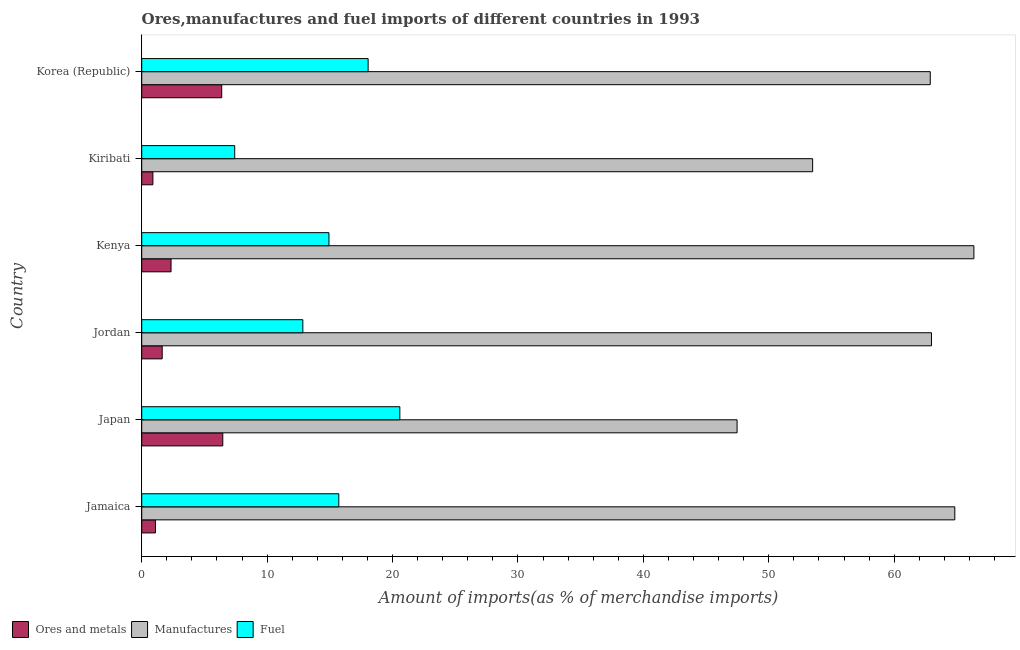How many different coloured bars are there?
Offer a terse response. 3. How many bars are there on the 2nd tick from the top?
Provide a short and direct response. 3. What is the label of the 3rd group of bars from the top?
Your answer should be compact. Kenya. In how many cases, is the number of bars for a given country not equal to the number of legend labels?
Offer a terse response. 0. What is the percentage of fuel imports in Jamaica?
Your answer should be compact. 15.72. Across all countries, what is the maximum percentage of fuel imports?
Offer a terse response. 20.58. Across all countries, what is the minimum percentage of manufactures imports?
Ensure brevity in your answer.  47.47. In which country was the percentage of manufactures imports minimum?
Give a very brief answer. Japan. What is the total percentage of ores and metals imports in the graph?
Your answer should be compact. 18.8. What is the difference between the percentage of fuel imports in Jordan and that in Kenya?
Keep it short and to the point. -2.08. What is the difference between the percentage of fuel imports in Korea (Republic) and the percentage of ores and metals imports in Jordan?
Ensure brevity in your answer.  16.42. What is the average percentage of fuel imports per country?
Keep it short and to the point. 14.92. What is the difference between the percentage of manufactures imports and percentage of fuel imports in Japan?
Your answer should be very brief. 26.89. What is the ratio of the percentage of manufactures imports in Jamaica to that in Korea (Republic)?
Offer a terse response. 1.03. Is the percentage of ores and metals imports in Kiribati less than that in Korea (Republic)?
Provide a succinct answer. Yes. What is the difference between the highest and the second highest percentage of ores and metals imports?
Keep it short and to the point. 0.08. What is the difference between the highest and the lowest percentage of ores and metals imports?
Ensure brevity in your answer.  5.57. In how many countries, is the percentage of manufactures imports greater than the average percentage of manufactures imports taken over all countries?
Provide a succinct answer. 4. Is the sum of the percentage of ores and metals imports in Japan and Jordan greater than the maximum percentage of manufactures imports across all countries?
Your answer should be compact. No. What does the 2nd bar from the top in Kiribati represents?
Keep it short and to the point. Manufactures. What does the 3rd bar from the bottom in Korea (Republic) represents?
Your response must be concise. Fuel. Is it the case that in every country, the sum of the percentage of ores and metals imports and percentage of manufactures imports is greater than the percentage of fuel imports?
Your response must be concise. Yes. How many countries are there in the graph?
Provide a succinct answer. 6. What is the difference between two consecutive major ticks on the X-axis?
Your answer should be very brief. 10. Are the values on the major ticks of X-axis written in scientific E-notation?
Make the answer very short. No. Does the graph contain any zero values?
Your answer should be compact. No. Where does the legend appear in the graph?
Keep it short and to the point. Bottom left. How are the legend labels stacked?
Make the answer very short. Horizontal. What is the title of the graph?
Your answer should be very brief. Ores,manufactures and fuel imports of different countries in 1993. What is the label or title of the X-axis?
Ensure brevity in your answer.  Amount of imports(as % of merchandise imports). What is the Amount of imports(as % of merchandise imports) of Ores and metals in Jamaica?
Your answer should be compact. 1.1. What is the Amount of imports(as % of merchandise imports) in Manufactures in Jamaica?
Make the answer very short. 64.84. What is the Amount of imports(as % of merchandise imports) in Fuel in Jamaica?
Offer a very short reply. 15.72. What is the Amount of imports(as % of merchandise imports) of Ores and metals in Japan?
Offer a terse response. 6.46. What is the Amount of imports(as % of merchandise imports) of Manufactures in Japan?
Offer a very short reply. 47.47. What is the Amount of imports(as % of merchandise imports) in Fuel in Japan?
Provide a short and direct response. 20.58. What is the Amount of imports(as % of merchandise imports) of Ores and metals in Jordan?
Offer a very short reply. 1.63. What is the Amount of imports(as % of merchandise imports) of Manufactures in Jordan?
Offer a terse response. 62.97. What is the Amount of imports(as % of merchandise imports) in Fuel in Jordan?
Your response must be concise. 12.85. What is the Amount of imports(as % of merchandise imports) of Ores and metals in Kenya?
Offer a terse response. 2.34. What is the Amount of imports(as % of merchandise imports) in Manufactures in Kenya?
Offer a very short reply. 66.36. What is the Amount of imports(as % of merchandise imports) of Fuel in Kenya?
Keep it short and to the point. 14.93. What is the Amount of imports(as % of merchandise imports) of Ores and metals in Kiribati?
Offer a very short reply. 0.89. What is the Amount of imports(as % of merchandise imports) in Manufactures in Kiribati?
Your response must be concise. 53.5. What is the Amount of imports(as % of merchandise imports) in Fuel in Kiribati?
Provide a short and direct response. 7.41. What is the Amount of imports(as % of merchandise imports) in Ores and metals in Korea (Republic)?
Ensure brevity in your answer.  6.38. What is the Amount of imports(as % of merchandise imports) of Manufactures in Korea (Republic)?
Your answer should be very brief. 62.88. What is the Amount of imports(as % of merchandise imports) in Fuel in Korea (Republic)?
Keep it short and to the point. 18.05. Across all countries, what is the maximum Amount of imports(as % of merchandise imports) in Ores and metals?
Offer a very short reply. 6.46. Across all countries, what is the maximum Amount of imports(as % of merchandise imports) in Manufactures?
Your response must be concise. 66.36. Across all countries, what is the maximum Amount of imports(as % of merchandise imports) of Fuel?
Provide a short and direct response. 20.58. Across all countries, what is the minimum Amount of imports(as % of merchandise imports) of Ores and metals?
Ensure brevity in your answer.  0.89. Across all countries, what is the minimum Amount of imports(as % of merchandise imports) of Manufactures?
Provide a short and direct response. 47.47. Across all countries, what is the minimum Amount of imports(as % of merchandise imports) of Fuel?
Your answer should be compact. 7.41. What is the total Amount of imports(as % of merchandise imports) in Ores and metals in the graph?
Provide a short and direct response. 18.8. What is the total Amount of imports(as % of merchandise imports) in Manufactures in the graph?
Your answer should be very brief. 358.02. What is the total Amount of imports(as % of merchandise imports) of Fuel in the graph?
Offer a terse response. 89.55. What is the difference between the Amount of imports(as % of merchandise imports) of Ores and metals in Jamaica and that in Japan?
Ensure brevity in your answer.  -5.37. What is the difference between the Amount of imports(as % of merchandise imports) of Manufactures in Jamaica and that in Japan?
Your answer should be compact. 17.36. What is the difference between the Amount of imports(as % of merchandise imports) in Fuel in Jamaica and that in Japan?
Your answer should be very brief. -4.87. What is the difference between the Amount of imports(as % of merchandise imports) of Ores and metals in Jamaica and that in Jordan?
Your answer should be compact. -0.54. What is the difference between the Amount of imports(as % of merchandise imports) of Manufactures in Jamaica and that in Jordan?
Your response must be concise. 1.86. What is the difference between the Amount of imports(as % of merchandise imports) of Fuel in Jamaica and that in Jordan?
Provide a short and direct response. 2.87. What is the difference between the Amount of imports(as % of merchandise imports) in Ores and metals in Jamaica and that in Kenya?
Offer a terse response. -1.24. What is the difference between the Amount of imports(as % of merchandise imports) of Manufactures in Jamaica and that in Kenya?
Your response must be concise. -1.52. What is the difference between the Amount of imports(as % of merchandise imports) in Fuel in Jamaica and that in Kenya?
Offer a very short reply. 0.79. What is the difference between the Amount of imports(as % of merchandise imports) in Ores and metals in Jamaica and that in Kiribati?
Offer a terse response. 0.21. What is the difference between the Amount of imports(as % of merchandise imports) in Manufactures in Jamaica and that in Kiribati?
Your answer should be compact. 11.34. What is the difference between the Amount of imports(as % of merchandise imports) of Fuel in Jamaica and that in Kiribati?
Offer a very short reply. 8.3. What is the difference between the Amount of imports(as % of merchandise imports) of Ores and metals in Jamaica and that in Korea (Republic)?
Keep it short and to the point. -5.28. What is the difference between the Amount of imports(as % of merchandise imports) of Manufactures in Jamaica and that in Korea (Republic)?
Your answer should be compact. 1.96. What is the difference between the Amount of imports(as % of merchandise imports) in Fuel in Jamaica and that in Korea (Republic)?
Make the answer very short. -2.34. What is the difference between the Amount of imports(as % of merchandise imports) of Ores and metals in Japan and that in Jordan?
Offer a very short reply. 4.83. What is the difference between the Amount of imports(as % of merchandise imports) of Manufactures in Japan and that in Jordan?
Your answer should be compact. -15.5. What is the difference between the Amount of imports(as % of merchandise imports) of Fuel in Japan and that in Jordan?
Keep it short and to the point. 7.73. What is the difference between the Amount of imports(as % of merchandise imports) in Ores and metals in Japan and that in Kenya?
Keep it short and to the point. 4.12. What is the difference between the Amount of imports(as % of merchandise imports) of Manufactures in Japan and that in Kenya?
Your response must be concise. -18.88. What is the difference between the Amount of imports(as % of merchandise imports) of Fuel in Japan and that in Kenya?
Keep it short and to the point. 5.65. What is the difference between the Amount of imports(as % of merchandise imports) in Ores and metals in Japan and that in Kiribati?
Your answer should be compact. 5.57. What is the difference between the Amount of imports(as % of merchandise imports) of Manufactures in Japan and that in Kiribati?
Give a very brief answer. -6.03. What is the difference between the Amount of imports(as % of merchandise imports) of Fuel in Japan and that in Kiribati?
Provide a succinct answer. 13.17. What is the difference between the Amount of imports(as % of merchandise imports) of Ores and metals in Japan and that in Korea (Republic)?
Provide a short and direct response. 0.08. What is the difference between the Amount of imports(as % of merchandise imports) of Manufactures in Japan and that in Korea (Republic)?
Provide a succinct answer. -15.4. What is the difference between the Amount of imports(as % of merchandise imports) of Fuel in Japan and that in Korea (Republic)?
Provide a short and direct response. 2.53. What is the difference between the Amount of imports(as % of merchandise imports) in Ores and metals in Jordan and that in Kenya?
Ensure brevity in your answer.  -0.71. What is the difference between the Amount of imports(as % of merchandise imports) of Manufactures in Jordan and that in Kenya?
Offer a terse response. -3.38. What is the difference between the Amount of imports(as % of merchandise imports) of Fuel in Jordan and that in Kenya?
Your answer should be very brief. -2.08. What is the difference between the Amount of imports(as % of merchandise imports) in Ores and metals in Jordan and that in Kiribati?
Ensure brevity in your answer.  0.74. What is the difference between the Amount of imports(as % of merchandise imports) in Manufactures in Jordan and that in Kiribati?
Ensure brevity in your answer.  9.48. What is the difference between the Amount of imports(as % of merchandise imports) of Fuel in Jordan and that in Kiribati?
Provide a succinct answer. 5.43. What is the difference between the Amount of imports(as % of merchandise imports) in Ores and metals in Jordan and that in Korea (Republic)?
Keep it short and to the point. -4.75. What is the difference between the Amount of imports(as % of merchandise imports) of Manufactures in Jordan and that in Korea (Republic)?
Provide a short and direct response. 0.1. What is the difference between the Amount of imports(as % of merchandise imports) of Fuel in Jordan and that in Korea (Republic)?
Your answer should be very brief. -5.2. What is the difference between the Amount of imports(as % of merchandise imports) in Ores and metals in Kenya and that in Kiribati?
Make the answer very short. 1.45. What is the difference between the Amount of imports(as % of merchandise imports) of Manufactures in Kenya and that in Kiribati?
Ensure brevity in your answer.  12.86. What is the difference between the Amount of imports(as % of merchandise imports) of Fuel in Kenya and that in Kiribati?
Provide a succinct answer. 7.51. What is the difference between the Amount of imports(as % of merchandise imports) of Ores and metals in Kenya and that in Korea (Republic)?
Provide a short and direct response. -4.04. What is the difference between the Amount of imports(as % of merchandise imports) in Manufactures in Kenya and that in Korea (Republic)?
Offer a terse response. 3.48. What is the difference between the Amount of imports(as % of merchandise imports) in Fuel in Kenya and that in Korea (Republic)?
Your answer should be compact. -3.12. What is the difference between the Amount of imports(as % of merchandise imports) of Ores and metals in Kiribati and that in Korea (Republic)?
Give a very brief answer. -5.49. What is the difference between the Amount of imports(as % of merchandise imports) of Manufactures in Kiribati and that in Korea (Republic)?
Ensure brevity in your answer.  -9.38. What is the difference between the Amount of imports(as % of merchandise imports) in Fuel in Kiribati and that in Korea (Republic)?
Offer a very short reply. -10.64. What is the difference between the Amount of imports(as % of merchandise imports) in Ores and metals in Jamaica and the Amount of imports(as % of merchandise imports) in Manufactures in Japan?
Your response must be concise. -46.38. What is the difference between the Amount of imports(as % of merchandise imports) of Ores and metals in Jamaica and the Amount of imports(as % of merchandise imports) of Fuel in Japan?
Offer a terse response. -19.49. What is the difference between the Amount of imports(as % of merchandise imports) of Manufactures in Jamaica and the Amount of imports(as % of merchandise imports) of Fuel in Japan?
Offer a very short reply. 44.25. What is the difference between the Amount of imports(as % of merchandise imports) of Ores and metals in Jamaica and the Amount of imports(as % of merchandise imports) of Manufactures in Jordan?
Your answer should be very brief. -61.88. What is the difference between the Amount of imports(as % of merchandise imports) of Ores and metals in Jamaica and the Amount of imports(as % of merchandise imports) of Fuel in Jordan?
Keep it short and to the point. -11.75. What is the difference between the Amount of imports(as % of merchandise imports) of Manufactures in Jamaica and the Amount of imports(as % of merchandise imports) of Fuel in Jordan?
Keep it short and to the point. 51.99. What is the difference between the Amount of imports(as % of merchandise imports) in Ores and metals in Jamaica and the Amount of imports(as % of merchandise imports) in Manufactures in Kenya?
Your response must be concise. -65.26. What is the difference between the Amount of imports(as % of merchandise imports) in Ores and metals in Jamaica and the Amount of imports(as % of merchandise imports) in Fuel in Kenya?
Keep it short and to the point. -13.83. What is the difference between the Amount of imports(as % of merchandise imports) in Manufactures in Jamaica and the Amount of imports(as % of merchandise imports) in Fuel in Kenya?
Offer a very short reply. 49.91. What is the difference between the Amount of imports(as % of merchandise imports) in Ores and metals in Jamaica and the Amount of imports(as % of merchandise imports) in Manufactures in Kiribati?
Offer a terse response. -52.4. What is the difference between the Amount of imports(as % of merchandise imports) of Ores and metals in Jamaica and the Amount of imports(as % of merchandise imports) of Fuel in Kiribati?
Provide a short and direct response. -6.32. What is the difference between the Amount of imports(as % of merchandise imports) in Manufactures in Jamaica and the Amount of imports(as % of merchandise imports) in Fuel in Kiribati?
Make the answer very short. 57.42. What is the difference between the Amount of imports(as % of merchandise imports) of Ores and metals in Jamaica and the Amount of imports(as % of merchandise imports) of Manufactures in Korea (Republic)?
Ensure brevity in your answer.  -61.78. What is the difference between the Amount of imports(as % of merchandise imports) of Ores and metals in Jamaica and the Amount of imports(as % of merchandise imports) of Fuel in Korea (Republic)?
Make the answer very short. -16.96. What is the difference between the Amount of imports(as % of merchandise imports) of Manufactures in Jamaica and the Amount of imports(as % of merchandise imports) of Fuel in Korea (Republic)?
Your response must be concise. 46.78. What is the difference between the Amount of imports(as % of merchandise imports) in Ores and metals in Japan and the Amount of imports(as % of merchandise imports) in Manufactures in Jordan?
Ensure brevity in your answer.  -56.51. What is the difference between the Amount of imports(as % of merchandise imports) of Ores and metals in Japan and the Amount of imports(as % of merchandise imports) of Fuel in Jordan?
Ensure brevity in your answer.  -6.38. What is the difference between the Amount of imports(as % of merchandise imports) in Manufactures in Japan and the Amount of imports(as % of merchandise imports) in Fuel in Jordan?
Provide a short and direct response. 34.63. What is the difference between the Amount of imports(as % of merchandise imports) of Ores and metals in Japan and the Amount of imports(as % of merchandise imports) of Manufactures in Kenya?
Provide a short and direct response. -59.89. What is the difference between the Amount of imports(as % of merchandise imports) in Ores and metals in Japan and the Amount of imports(as % of merchandise imports) in Fuel in Kenya?
Your answer should be very brief. -8.47. What is the difference between the Amount of imports(as % of merchandise imports) of Manufactures in Japan and the Amount of imports(as % of merchandise imports) of Fuel in Kenya?
Offer a very short reply. 32.54. What is the difference between the Amount of imports(as % of merchandise imports) in Ores and metals in Japan and the Amount of imports(as % of merchandise imports) in Manufactures in Kiribati?
Your answer should be compact. -47.04. What is the difference between the Amount of imports(as % of merchandise imports) of Ores and metals in Japan and the Amount of imports(as % of merchandise imports) of Fuel in Kiribati?
Ensure brevity in your answer.  -0.95. What is the difference between the Amount of imports(as % of merchandise imports) in Manufactures in Japan and the Amount of imports(as % of merchandise imports) in Fuel in Kiribati?
Provide a succinct answer. 40.06. What is the difference between the Amount of imports(as % of merchandise imports) of Ores and metals in Japan and the Amount of imports(as % of merchandise imports) of Manufactures in Korea (Republic)?
Your response must be concise. -56.41. What is the difference between the Amount of imports(as % of merchandise imports) in Ores and metals in Japan and the Amount of imports(as % of merchandise imports) in Fuel in Korea (Republic)?
Offer a very short reply. -11.59. What is the difference between the Amount of imports(as % of merchandise imports) in Manufactures in Japan and the Amount of imports(as % of merchandise imports) in Fuel in Korea (Republic)?
Your answer should be very brief. 29.42. What is the difference between the Amount of imports(as % of merchandise imports) in Ores and metals in Jordan and the Amount of imports(as % of merchandise imports) in Manufactures in Kenya?
Offer a terse response. -64.73. What is the difference between the Amount of imports(as % of merchandise imports) of Ores and metals in Jordan and the Amount of imports(as % of merchandise imports) of Fuel in Kenya?
Provide a short and direct response. -13.3. What is the difference between the Amount of imports(as % of merchandise imports) in Manufactures in Jordan and the Amount of imports(as % of merchandise imports) in Fuel in Kenya?
Offer a very short reply. 48.04. What is the difference between the Amount of imports(as % of merchandise imports) of Ores and metals in Jordan and the Amount of imports(as % of merchandise imports) of Manufactures in Kiribati?
Keep it short and to the point. -51.87. What is the difference between the Amount of imports(as % of merchandise imports) of Ores and metals in Jordan and the Amount of imports(as % of merchandise imports) of Fuel in Kiribati?
Provide a short and direct response. -5.78. What is the difference between the Amount of imports(as % of merchandise imports) in Manufactures in Jordan and the Amount of imports(as % of merchandise imports) in Fuel in Kiribati?
Give a very brief answer. 55.56. What is the difference between the Amount of imports(as % of merchandise imports) in Ores and metals in Jordan and the Amount of imports(as % of merchandise imports) in Manufactures in Korea (Republic)?
Provide a succinct answer. -61.25. What is the difference between the Amount of imports(as % of merchandise imports) in Ores and metals in Jordan and the Amount of imports(as % of merchandise imports) in Fuel in Korea (Republic)?
Provide a succinct answer. -16.42. What is the difference between the Amount of imports(as % of merchandise imports) of Manufactures in Jordan and the Amount of imports(as % of merchandise imports) of Fuel in Korea (Republic)?
Your answer should be very brief. 44.92. What is the difference between the Amount of imports(as % of merchandise imports) of Ores and metals in Kenya and the Amount of imports(as % of merchandise imports) of Manufactures in Kiribati?
Provide a succinct answer. -51.16. What is the difference between the Amount of imports(as % of merchandise imports) of Ores and metals in Kenya and the Amount of imports(as % of merchandise imports) of Fuel in Kiribati?
Keep it short and to the point. -5.08. What is the difference between the Amount of imports(as % of merchandise imports) in Manufactures in Kenya and the Amount of imports(as % of merchandise imports) in Fuel in Kiribati?
Keep it short and to the point. 58.94. What is the difference between the Amount of imports(as % of merchandise imports) in Ores and metals in Kenya and the Amount of imports(as % of merchandise imports) in Manufactures in Korea (Republic)?
Give a very brief answer. -60.54. What is the difference between the Amount of imports(as % of merchandise imports) in Ores and metals in Kenya and the Amount of imports(as % of merchandise imports) in Fuel in Korea (Republic)?
Provide a short and direct response. -15.71. What is the difference between the Amount of imports(as % of merchandise imports) in Manufactures in Kenya and the Amount of imports(as % of merchandise imports) in Fuel in Korea (Republic)?
Provide a succinct answer. 48.3. What is the difference between the Amount of imports(as % of merchandise imports) in Ores and metals in Kiribati and the Amount of imports(as % of merchandise imports) in Manufactures in Korea (Republic)?
Your response must be concise. -61.99. What is the difference between the Amount of imports(as % of merchandise imports) of Ores and metals in Kiribati and the Amount of imports(as % of merchandise imports) of Fuel in Korea (Republic)?
Ensure brevity in your answer.  -17.16. What is the difference between the Amount of imports(as % of merchandise imports) in Manufactures in Kiribati and the Amount of imports(as % of merchandise imports) in Fuel in Korea (Republic)?
Give a very brief answer. 35.45. What is the average Amount of imports(as % of merchandise imports) in Ores and metals per country?
Give a very brief answer. 3.13. What is the average Amount of imports(as % of merchandise imports) in Manufactures per country?
Ensure brevity in your answer.  59.67. What is the average Amount of imports(as % of merchandise imports) in Fuel per country?
Your answer should be compact. 14.92. What is the difference between the Amount of imports(as % of merchandise imports) in Ores and metals and Amount of imports(as % of merchandise imports) in Manufactures in Jamaica?
Offer a terse response. -63.74. What is the difference between the Amount of imports(as % of merchandise imports) in Ores and metals and Amount of imports(as % of merchandise imports) in Fuel in Jamaica?
Your answer should be very brief. -14.62. What is the difference between the Amount of imports(as % of merchandise imports) of Manufactures and Amount of imports(as % of merchandise imports) of Fuel in Jamaica?
Your response must be concise. 49.12. What is the difference between the Amount of imports(as % of merchandise imports) of Ores and metals and Amount of imports(as % of merchandise imports) of Manufactures in Japan?
Make the answer very short. -41.01. What is the difference between the Amount of imports(as % of merchandise imports) in Ores and metals and Amount of imports(as % of merchandise imports) in Fuel in Japan?
Keep it short and to the point. -14.12. What is the difference between the Amount of imports(as % of merchandise imports) in Manufactures and Amount of imports(as % of merchandise imports) in Fuel in Japan?
Give a very brief answer. 26.89. What is the difference between the Amount of imports(as % of merchandise imports) of Ores and metals and Amount of imports(as % of merchandise imports) of Manufactures in Jordan?
Make the answer very short. -61.34. What is the difference between the Amount of imports(as % of merchandise imports) of Ores and metals and Amount of imports(as % of merchandise imports) of Fuel in Jordan?
Provide a short and direct response. -11.22. What is the difference between the Amount of imports(as % of merchandise imports) of Manufactures and Amount of imports(as % of merchandise imports) of Fuel in Jordan?
Offer a terse response. 50.13. What is the difference between the Amount of imports(as % of merchandise imports) in Ores and metals and Amount of imports(as % of merchandise imports) in Manufactures in Kenya?
Make the answer very short. -64.02. What is the difference between the Amount of imports(as % of merchandise imports) of Ores and metals and Amount of imports(as % of merchandise imports) of Fuel in Kenya?
Provide a succinct answer. -12.59. What is the difference between the Amount of imports(as % of merchandise imports) in Manufactures and Amount of imports(as % of merchandise imports) in Fuel in Kenya?
Provide a succinct answer. 51.43. What is the difference between the Amount of imports(as % of merchandise imports) in Ores and metals and Amount of imports(as % of merchandise imports) in Manufactures in Kiribati?
Provide a short and direct response. -52.61. What is the difference between the Amount of imports(as % of merchandise imports) in Ores and metals and Amount of imports(as % of merchandise imports) in Fuel in Kiribati?
Give a very brief answer. -6.52. What is the difference between the Amount of imports(as % of merchandise imports) in Manufactures and Amount of imports(as % of merchandise imports) in Fuel in Kiribati?
Ensure brevity in your answer.  46.08. What is the difference between the Amount of imports(as % of merchandise imports) in Ores and metals and Amount of imports(as % of merchandise imports) in Manufactures in Korea (Republic)?
Offer a very short reply. -56.5. What is the difference between the Amount of imports(as % of merchandise imports) of Ores and metals and Amount of imports(as % of merchandise imports) of Fuel in Korea (Republic)?
Provide a succinct answer. -11.67. What is the difference between the Amount of imports(as % of merchandise imports) in Manufactures and Amount of imports(as % of merchandise imports) in Fuel in Korea (Republic)?
Give a very brief answer. 44.83. What is the ratio of the Amount of imports(as % of merchandise imports) in Ores and metals in Jamaica to that in Japan?
Your answer should be very brief. 0.17. What is the ratio of the Amount of imports(as % of merchandise imports) of Manufactures in Jamaica to that in Japan?
Offer a terse response. 1.37. What is the ratio of the Amount of imports(as % of merchandise imports) in Fuel in Jamaica to that in Japan?
Ensure brevity in your answer.  0.76. What is the ratio of the Amount of imports(as % of merchandise imports) of Ores and metals in Jamaica to that in Jordan?
Keep it short and to the point. 0.67. What is the ratio of the Amount of imports(as % of merchandise imports) in Manufactures in Jamaica to that in Jordan?
Your answer should be very brief. 1.03. What is the ratio of the Amount of imports(as % of merchandise imports) in Fuel in Jamaica to that in Jordan?
Keep it short and to the point. 1.22. What is the ratio of the Amount of imports(as % of merchandise imports) of Ores and metals in Jamaica to that in Kenya?
Make the answer very short. 0.47. What is the ratio of the Amount of imports(as % of merchandise imports) of Manufactures in Jamaica to that in Kenya?
Ensure brevity in your answer.  0.98. What is the ratio of the Amount of imports(as % of merchandise imports) of Fuel in Jamaica to that in Kenya?
Keep it short and to the point. 1.05. What is the ratio of the Amount of imports(as % of merchandise imports) of Ores and metals in Jamaica to that in Kiribati?
Your answer should be compact. 1.23. What is the ratio of the Amount of imports(as % of merchandise imports) of Manufactures in Jamaica to that in Kiribati?
Make the answer very short. 1.21. What is the ratio of the Amount of imports(as % of merchandise imports) in Fuel in Jamaica to that in Kiribati?
Make the answer very short. 2.12. What is the ratio of the Amount of imports(as % of merchandise imports) of Ores and metals in Jamaica to that in Korea (Republic)?
Give a very brief answer. 0.17. What is the ratio of the Amount of imports(as % of merchandise imports) of Manufactures in Jamaica to that in Korea (Republic)?
Give a very brief answer. 1.03. What is the ratio of the Amount of imports(as % of merchandise imports) in Fuel in Jamaica to that in Korea (Republic)?
Provide a succinct answer. 0.87. What is the ratio of the Amount of imports(as % of merchandise imports) in Ores and metals in Japan to that in Jordan?
Ensure brevity in your answer.  3.96. What is the ratio of the Amount of imports(as % of merchandise imports) in Manufactures in Japan to that in Jordan?
Keep it short and to the point. 0.75. What is the ratio of the Amount of imports(as % of merchandise imports) in Fuel in Japan to that in Jordan?
Offer a terse response. 1.6. What is the ratio of the Amount of imports(as % of merchandise imports) in Ores and metals in Japan to that in Kenya?
Provide a short and direct response. 2.76. What is the ratio of the Amount of imports(as % of merchandise imports) of Manufactures in Japan to that in Kenya?
Make the answer very short. 0.72. What is the ratio of the Amount of imports(as % of merchandise imports) of Fuel in Japan to that in Kenya?
Your answer should be compact. 1.38. What is the ratio of the Amount of imports(as % of merchandise imports) in Ores and metals in Japan to that in Kiribati?
Offer a terse response. 7.26. What is the ratio of the Amount of imports(as % of merchandise imports) in Manufactures in Japan to that in Kiribati?
Your answer should be compact. 0.89. What is the ratio of the Amount of imports(as % of merchandise imports) in Fuel in Japan to that in Kiribati?
Your answer should be very brief. 2.78. What is the ratio of the Amount of imports(as % of merchandise imports) in Ores and metals in Japan to that in Korea (Republic)?
Make the answer very short. 1.01. What is the ratio of the Amount of imports(as % of merchandise imports) in Manufactures in Japan to that in Korea (Republic)?
Your response must be concise. 0.76. What is the ratio of the Amount of imports(as % of merchandise imports) of Fuel in Japan to that in Korea (Republic)?
Offer a very short reply. 1.14. What is the ratio of the Amount of imports(as % of merchandise imports) in Ores and metals in Jordan to that in Kenya?
Provide a succinct answer. 0.7. What is the ratio of the Amount of imports(as % of merchandise imports) of Manufactures in Jordan to that in Kenya?
Your answer should be compact. 0.95. What is the ratio of the Amount of imports(as % of merchandise imports) in Fuel in Jordan to that in Kenya?
Provide a succinct answer. 0.86. What is the ratio of the Amount of imports(as % of merchandise imports) in Ores and metals in Jordan to that in Kiribati?
Provide a short and direct response. 1.83. What is the ratio of the Amount of imports(as % of merchandise imports) in Manufactures in Jordan to that in Kiribati?
Your response must be concise. 1.18. What is the ratio of the Amount of imports(as % of merchandise imports) in Fuel in Jordan to that in Kiribati?
Provide a succinct answer. 1.73. What is the ratio of the Amount of imports(as % of merchandise imports) of Ores and metals in Jordan to that in Korea (Republic)?
Your answer should be compact. 0.26. What is the ratio of the Amount of imports(as % of merchandise imports) of Fuel in Jordan to that in Korea (Republic)?
Keep it short and to the point. 0.71. What is the ratio of the Amount of imports(as % of merchandise imports) of Ores and metals in Kenya to that in Kiribati?
Give a very brief answer. 2.63. What is the ratio of the Amount of imports(as % of merchandise imports) in Manufactures in Kenya to that in Kiribati?
Your answer should be very brief. 1.24. What is the ratio of the Amount of imports(as % of merchandise imports) of Fuel in Kenya to that in Kiribati?
Your response must be concise. 2.01. What is the ratio of the Amount of imports(as % of merchandise imports) in Ores and metals in Kenya to that in Korea (Republic)?
Your answer should be compact. 0.37. What is the ratio of the Amount of imports(as % of merchandise imports) in Manufactures in Kenya to that in Korea (Republic)?
Offer a very short reply. 1.06. What is the ratio of the Amount of imports(as % of merchandise imports) of Fuel in Kenya to that in Korea (Republic)?
Keep it short and to the point. 0.83. What is the ratio of the Amount of imports(as % of merchandise imports) of Ores and metals in Kiribati to that in Korea (Republic)?
Keep it short and to the point. 0.14. What is the ratio of the Amount of imports(as % of merchandise imports) in Manufactures in Kiribati to that in Korea (Republic)?
Your answer should be very brief. 0.85. What is the ratio of the Amount of imports(as % of merchandise imports) in Fuel in Kiribati to that in Korea (Republic)?
Make the answer very short. 0.41. What is the difference between the highest and the second highest Amount of imports(as % of merchandise imports) of Ores and metals?
Keep it short and to the point. 0.08. What is the difference between the highest and the second highest Amount of imports(as % of merchandise imports) in Manufactures?
Provide a short and direct response. 1.52. What is the difference between the highest and the second highest Amount of imports(as % of merchandise imports) of Fuel?
Provide a short and direct response. 2.53. What is the difference between the highest and the lowest Amount of imports(as % of merchandise imports) in Ores and metals?
Provide a short and direct response. 5.57. What is the difference between the highest and the lowest Amount of imports(as % of merchandise imports) of Manufactures?
Offer a very short reply. 18.88. What is the difference between the highest and the lowest Amount of imports(as % of merchandise imports) in Fuel?
Provide a succinct answer. 13.17. 